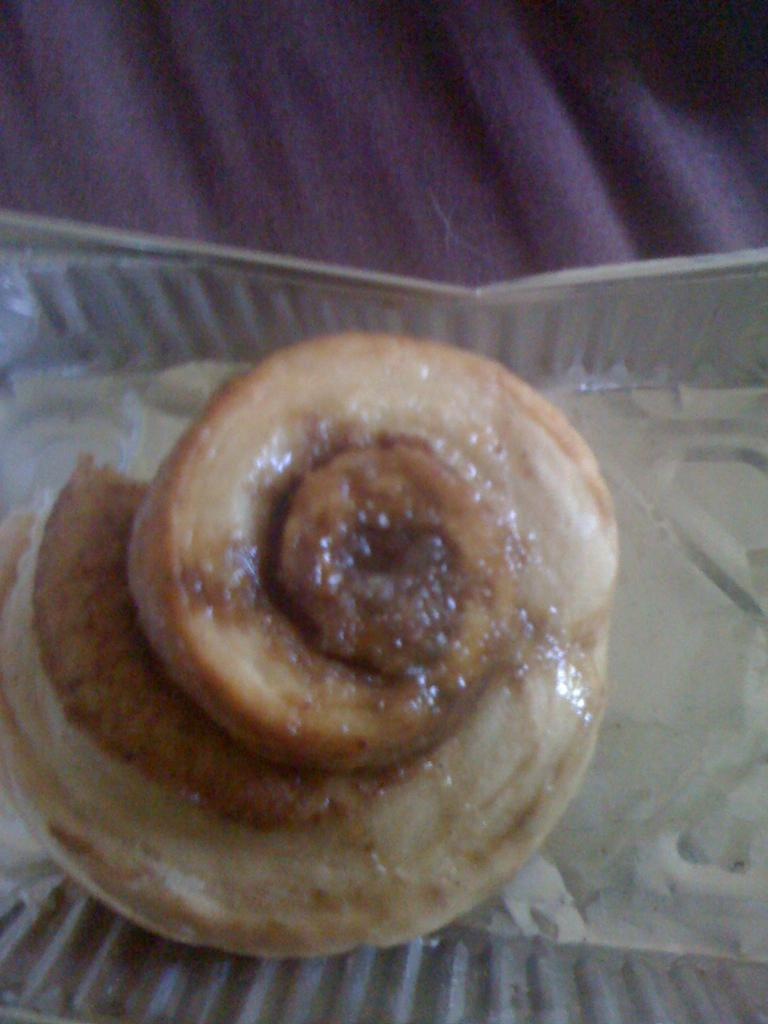What is contained within the box in the image? There is food in a box in the image. Can you describe the type of food in the box? The specific type of food in the box is not mentioned in the provided facts. What might be a possible use for the food in the box? The food in the box could be used for consumption or as an ingredient in a recipe. What type of plantation can be seen in the background of the image? There is no plantation visible in the image; it only shows food in a box. 